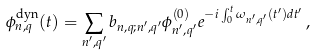Convert formula to latex. <formula><loc_0><loc_0><loc_500><loc_500>\phi ^ { \text {dyn} } _ { n , q } ( t ) = \sum _ { n ^ { \prime } , q ^ { \prime } } b _ { n , q ; n ^ { \prime } , q ^ { \prime } } \phi ^ { ( 0 ) } _ { n ^ { \prime } , q ^ { \prime } } e ^ { - i \int _ { 0 } ^ { t } \omega _ { n ^ { \prime } , q ^ { \prime } } ( t ^ { \prime } ) d t ^ { \prime } } \, ,</formula> 